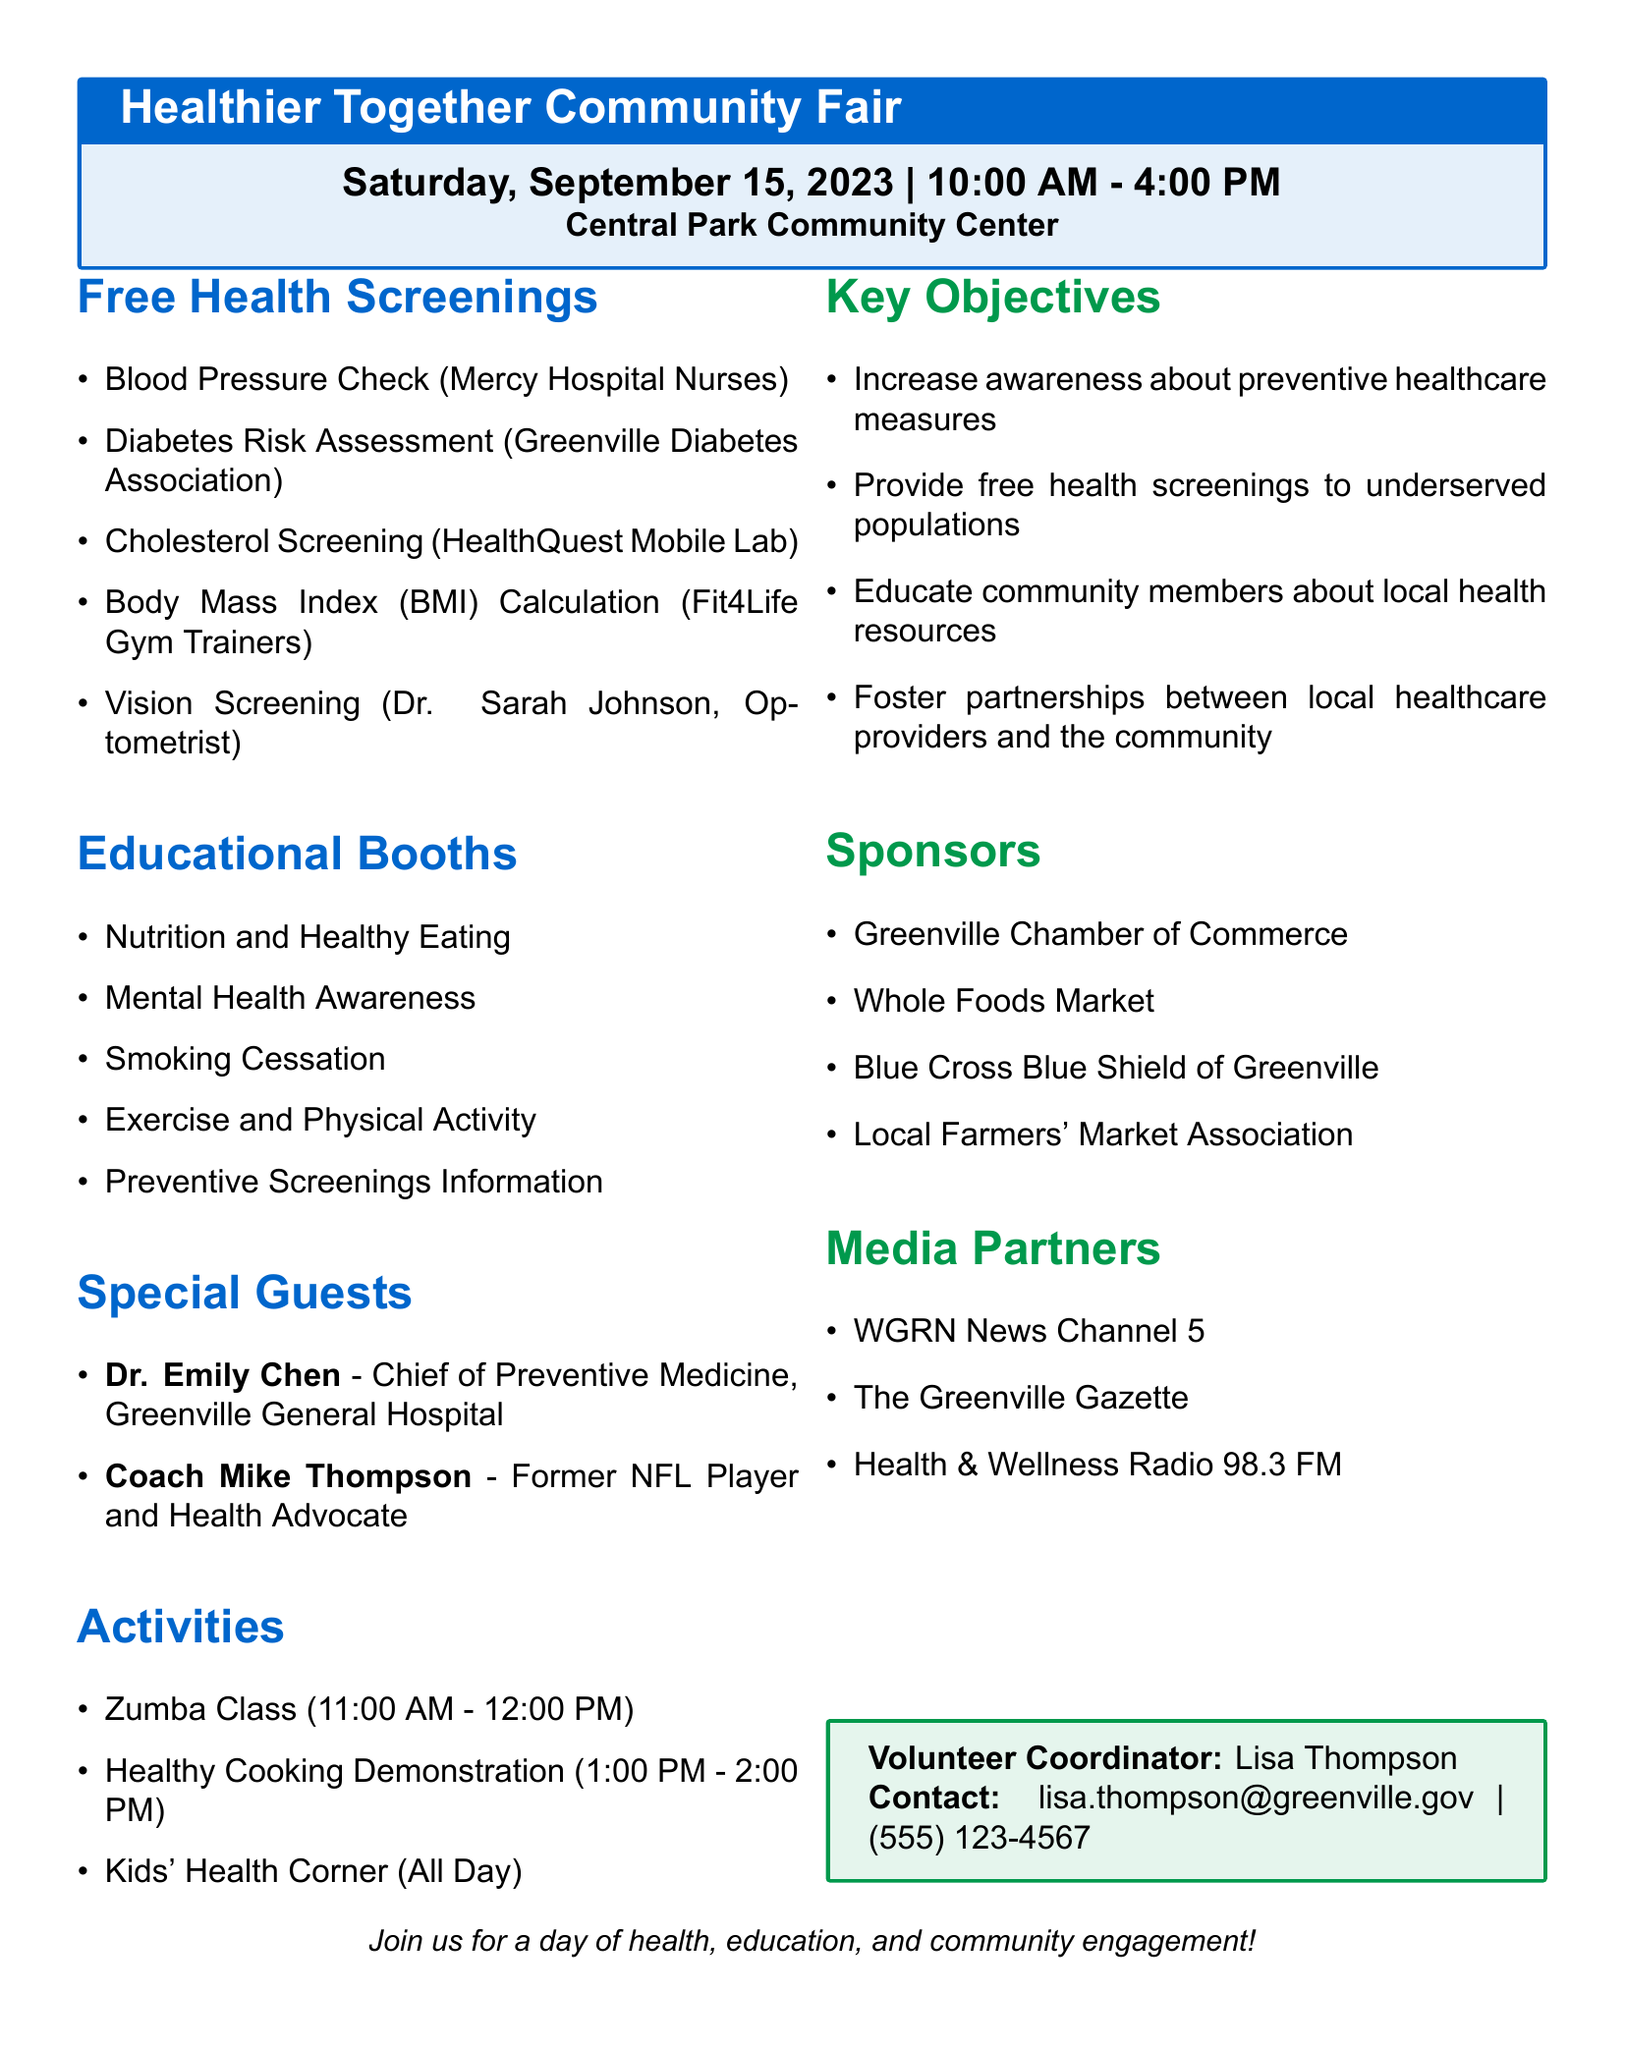What is the event date? The event date is explicitly mentioned in the document as Saturday, September 15, 2023.
Answer: Saturday, September 15, 2023 What time does the Healthier Together Community Fair start? The event time indicates that the fair starts at 10:00 AM.
Answer: 10:00 AM Who is providing the cholesterol screening? The provider listed for the cholesterol screening is HealthQuest Mobile Lab.
Answer: HealthQuest Mobile Lab What is one of the key objectives of the community fair? The document lists key objectives, and one mentioned is to increase awareness about preventive healthcare measures.
Answer: Increase awareness about preventive healthcare measures How many special guests are mentioned in the document? The document lists a total of two special guests.
Answer: 2 What is the topic presented by Dr. Emily Chen? Dr. Emily Chen's topic is "The Importance of Regular Health Check-ups."
Answer: The Importance of Regular Health Check-ups What activity is scheduled between 1:00 PM and 2:00 PM? The activity scheduled during that time is the Healthy Cooking Demonstration.
Answer: Healthy Cooking Demonstration What organization is responsible for the Nutrition and Healthy Eating booth? The document indicates that the Greenville Nutritionists Association organizes the Nutrition and Healthy Eating booth.
Answer: Greenville Nutritionists Association What type of event is the Healthier Together Community Fair? The document describes it as a comprehensive health fair.
Answer: Comprehensive health fair 